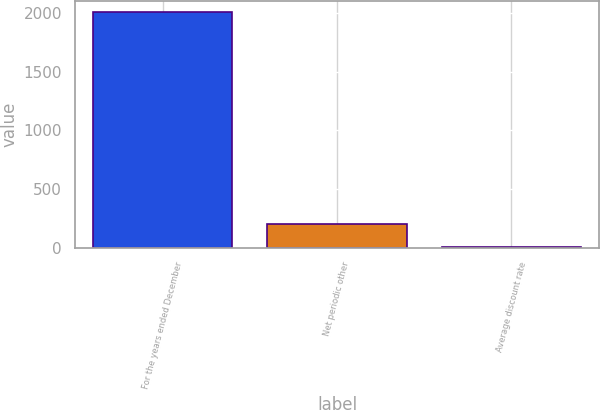<chart> <loc_0><loc_0><loc_500><loc_500><bar_chart><fcel>For the years ended December<fcel>Net periodic other<fcel>Average discount rate<nl><fcel>2006<fcel>205.46<fcel>5.4<nl></chart> 